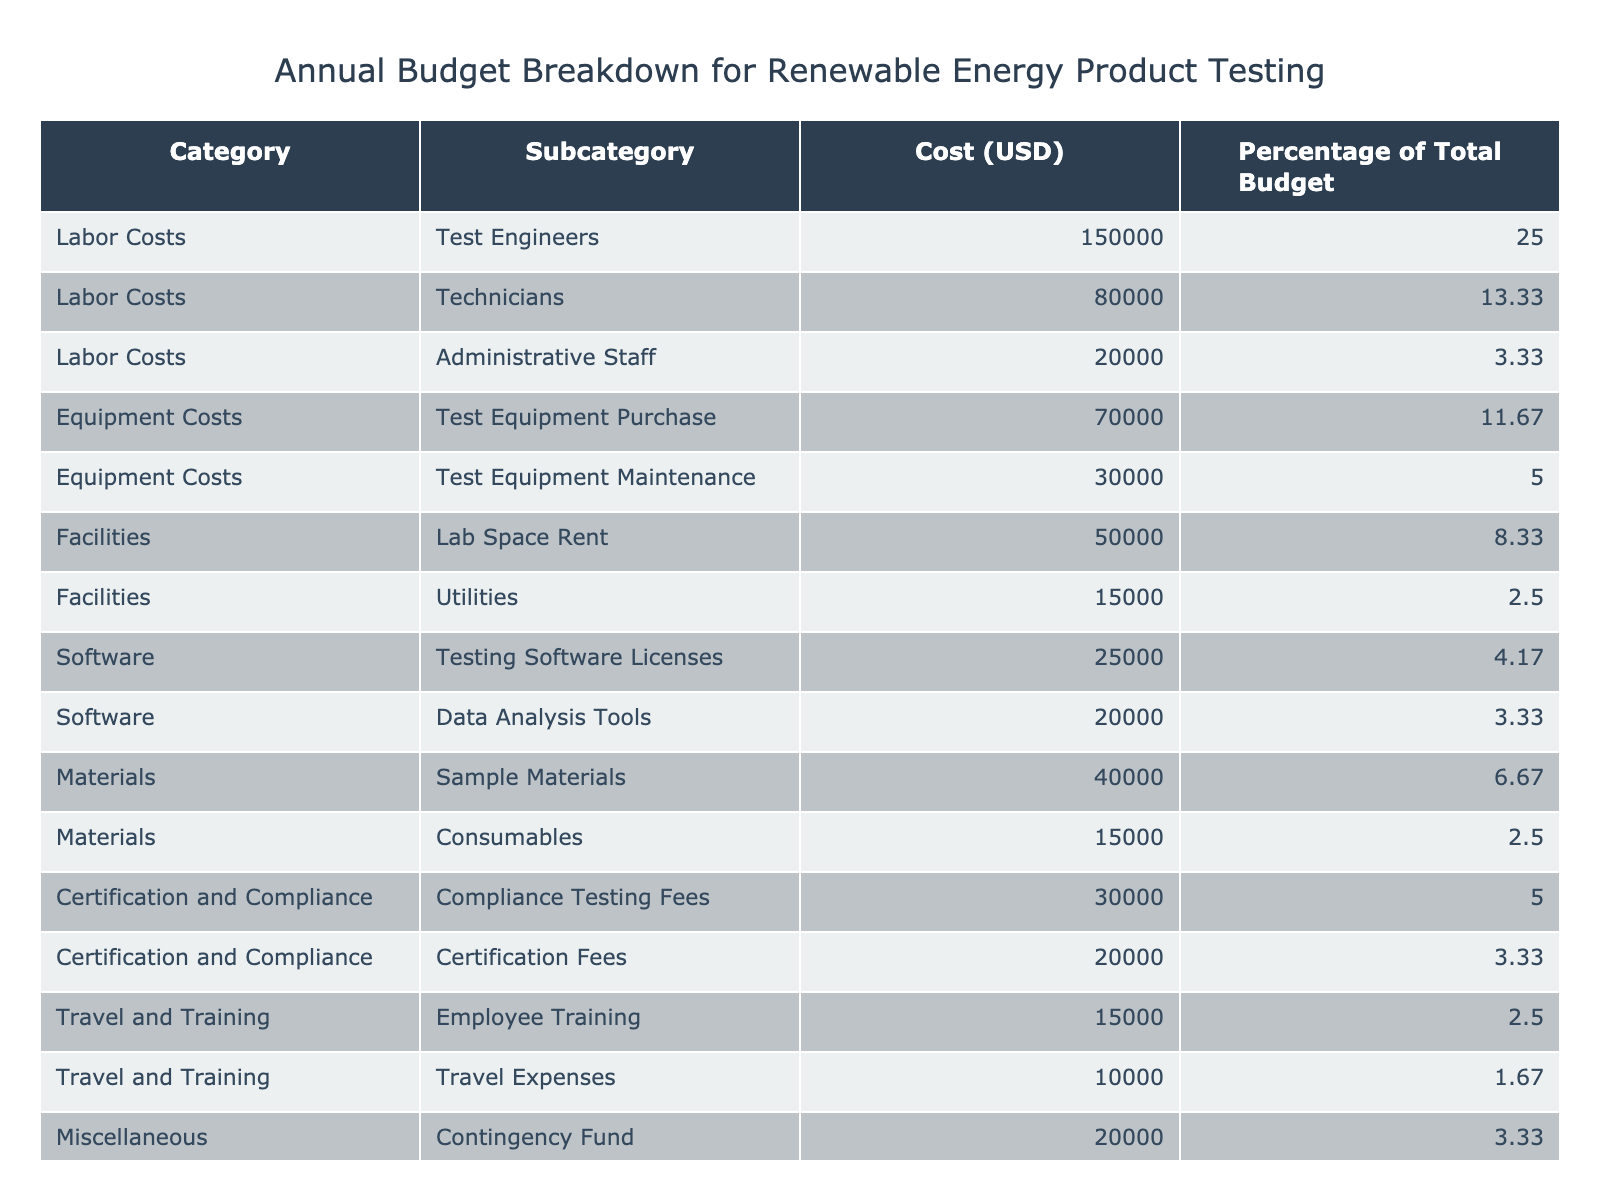What is the total cost allocated for labor costs? The total labor costs can be found by adding together the costs for test engineers, technicians, and administrative staff: 150,000 + 80,000 + 20,000 = 250,000.
Answer: 250,000 What percentage of the total budget is allocated to equipment costs? To find the total equipment costs percentage, add the percentages for test equipment purchase and test equipment maintenance: 11.67 + 5 = 16.67.
Answer: 16.67 Are the certification fees greater than the compliance testing fees? By looking at the respective costs, certification fees are 20,000, while compliance testing fees are 30,000. Since 20,000 is less than 30,000, the statement is false.
Answer: No What is the combined total cost for all miscellaneous items? The only miscellaneous item listed is the contingency fund, which costs 20,000. Since it is the only related cost, the total is simply 20,000.
Answer: 20,000 What is the average cost for labor costs based on the provided categories? To find the average labor cost, sum the individual costs for the three labor categories (150,000 + 80,000 + 20,000) to get 250,000, and then divide by 3: 250,000/3 ≈ 83,333.33.
Answer: 83,333.33 What is the cost allocation difference between sample materials and consumables? The cost for sample materials is 40,000, while the cost for consumables is 15,000. The difference between these two is 40,000 - 15,000 = 25,000.
Answer: 25,000 Is the cost of test equipment purchase more than the combined costs of employee training and travel expenses? The cost of test equipment purchase is 70,000. The sum of employee training (15,000) and travel expenses (10,000) is 25,000. Since 70,000 is greater than 25,000, the answer is yes.
Answer: Yes What percentage of the total budget is allocated to utilities compared to total certification and compliance costs? The utility cost is 15,000, which is about 2.5% of the total budget. The total certification and compliance costs (30,000 + 20,000) is 50,000. Thus, the percentage of total budget for certification and compliance is 50,000 divided by the total budget. The answer requires further information about the total budget.
Answer: Requires total budget for precise calculation Which category has the highest individual cost, and what is that cost? The highest individual cost is found by comparing all costs in each category. Test engineers (150,000) has the highest individual cost compared to other items.
Answer: 150,000 